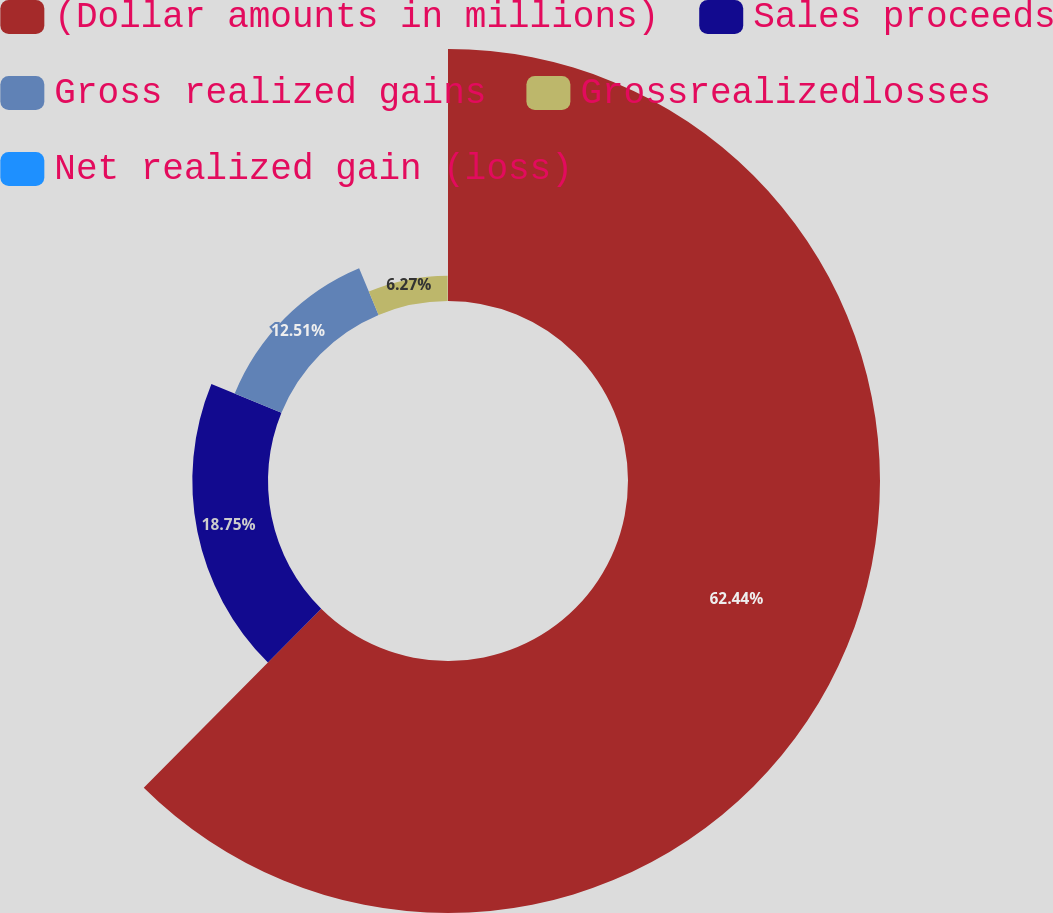<chart> <loc_0><loc_0><loc_500><loc_500><pie_chart><fcel>(Dollar amounts in millions)<fcel>Sales proceeds<fcel>Gross realized gains<fcel>Grossrealizedlosses<fcel>Net realized gain (loss)<nl><fcel>62.43%<fcel>18.75%<fcel>12.51%<fcel>6.27%<fcel>0.03%<nl></chart> 